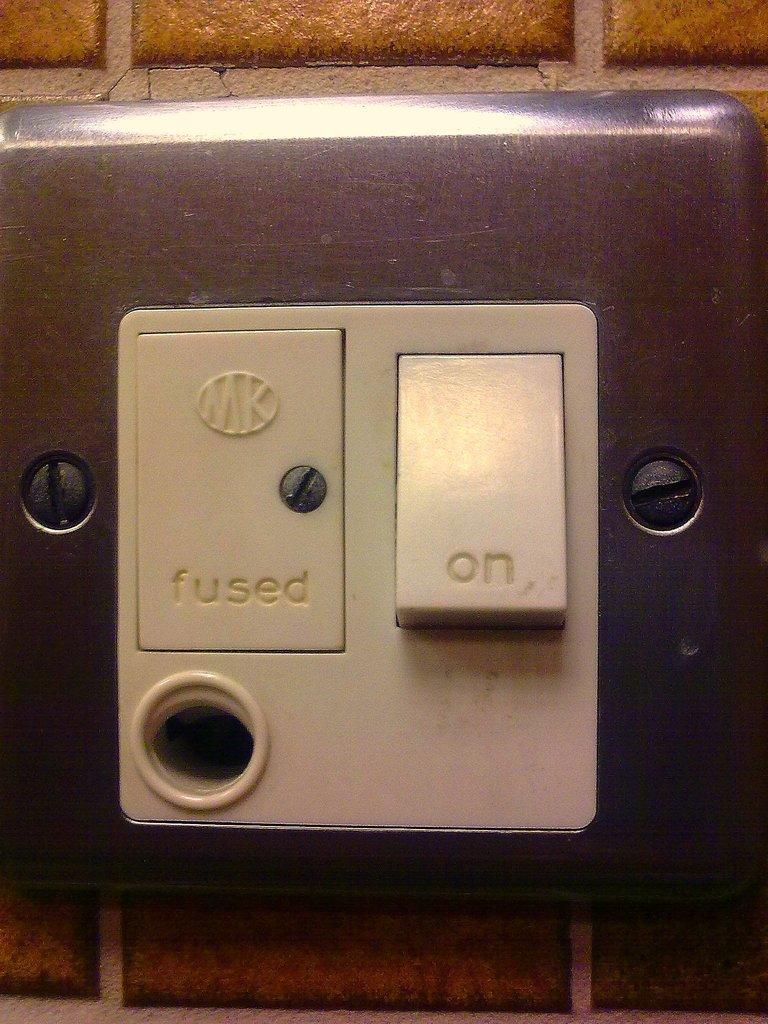<image>
Share a concise interpretation of the image provided. a switch on a wall that says 'fused' and 'on' 